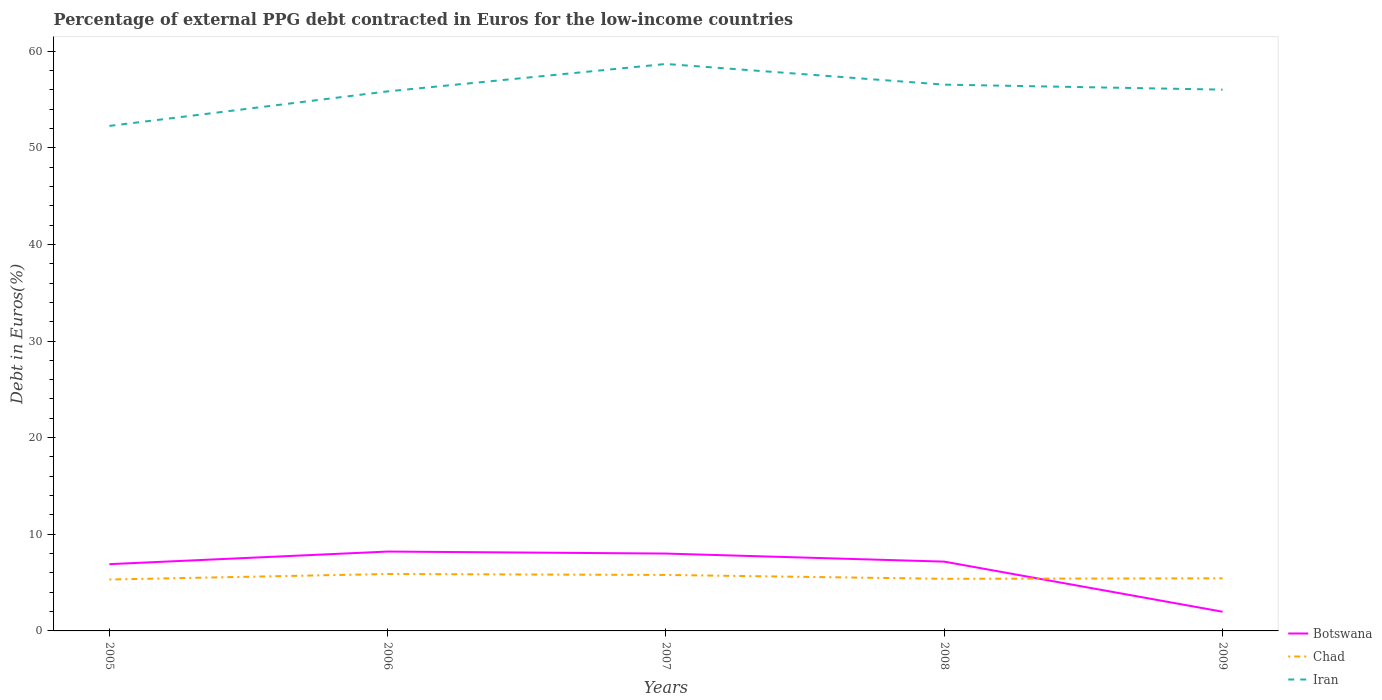Across all years, what is the maximum percentage of external PPG debt contracted in Euros in Chad?
Provide a succinct answer. 5.32. In which year was the percentage of external PPG debt contracted in Euros in Iran maximum?
Your answer should be compact. 2005. What is the total percentage of external PPG debt contracted in Euros in Iran in the graph?
Your answer should be compact. 2.66. What is the difference between the highest and the second highest percentage of external PPG debt contracted in Euros in Chad?
Provide a short and direct response. 0.57. What is the difference between the highest and the lowest percentage of external PPG debt contracted in Euros in Chad?
Offer a very short reply. 2. How many lines are there?
Keep it short and to the point. 3. How many years are there in the graph?
Your answer should be very brief. 5. What is the difference between two consecutive major ticks on the Y-axis?
Your response must be concise. 10. Does the graph contain any zero values?
Give a very brief answer. No. Where does the legend appear in the graph?
Provide a succinct answer. Bottom right. How many legend labels are there?
Ensure brevity in your answer.  3. What is the title of the graph?
Provide a short and direct response. Percentage of external PPG debt contracted in Euros for the low-income countries. What is the label or title of the X-axis?
Make the answer very short. Years. What is the label or title of the Y-axis?
Give a very brief answer. Debt in Euros(%). What is the Debt in Euros(%) of Botswana in 2005?
Ensure brevity in your answer.  6.91. What is the Debt in Euros(%) in Chad in 2005?
Ensure brevity in your answer.  5.32. What is the Debt in Euros(%) in Iran in 2005?
Give a very brief answer. 52.26. What is the Debt in Euros(%) in Botswana in 2006?
Your answer should be very brief. 8.21. What is the Debt in Euros(%) in Chad in 2006?
Keep it short and to the point. 5.89. What is the Debt in Euros(%) of Iran in 2006?
Give a very brief answer. 55.83. What is the Debt in Euros(%) in Botswana in 2007?
Your answer should be very brief. 8. What is the Debt in Euros(%) in Chad in 2007?
Make the answer very short. 5.79. What is the Debt in Euros(%) of Iran in 2007?
Your response must be concise. 58.67. What is the Debt in Euros(%) of Botswana in 2008?
Your answer should be compact. 7.17. What is the Debt in Euros(%) of Chad in 2008?
Offer a terse response. 5.39. What is the Debt in Euros(%) in Iran in 2008?
Make the answer very short. 56.53. What is the Debt in Euros(%) of Botswana in 2009?
Give a very brief answer. 1.99. What is the Debt in Euros(%) in Chad in 2009?
Provide a short and direct response. 5.44. What is the Debt in Euros(%) of Iran in 2009?
Provide a succinct answer. 56.01. Across all years, what is the maximum Debt in Euros(%) of Botswana?
Your answer should be compact. 8.21. Across all years, what is the maximum Debt in Euros(%) in Chad?
Ensure brevity in your answer.  5.89. Across all years, what is the maximum Debt in Euros(%) of Iran?
Your response must be concise. 58.67. Across all years, what is the minimum Debt in Euros(%) in Botswana?
Provide a short and direct response. 1.99. Across all years, what is the minimum Debt in Euros(%) in Chad?
Offer a terse response. 5.32. Across all years, what is the minimum Debt in Euros(%) of Iran?
Your answer should be very brief. 52.26. What is the total Debt in Euros(%) in Botswana in the graph?
Provide a short and direct response. 32.28. What is the total Debt in Euros(%) of Chad in the graph?
Ensure brevity in your answer.  27.84. What is the total Debt in Euros(%) of Iran in the graph?
Offer a very short reply. 279.31. What is the difference between the Debt in Euros(%) in Botswana in 2005 and that in 2006?
Offer a terse response. -1.3. What is the difference between the Debt in Euros(%) of Chad in 2005 and that in 2006?
Offer a terse response. -0.57. What is the difference between the Debt in Euros(%) in Iran in 2005 and that in 2006?
Your response must be concise. -3.58. What is the difference between the Debt in Euros(%) of Botswana in 2005 and that in 2007?
Ensure brevity in your answer.  -1.1. What is the difference between the Debt in Euros(%) in Chad in 2005 and that in 2007?
Your response must be concise. -0.47. What is the difference between the Debt in Euros(%) of Iran in 2005 and that in 2007?
Give a very brief answer. -6.41. What is the difference between the Debt in Euros(%) of Botswana in 2005 and that in 2008?
Your response must be concise. -0.26. What is the difference between the Debt in Euros(%) of Chad in 2005 and that in 2008?
Keep it short and to the point. -0.07. What is the difference between the Debt in Euros(%) of Iran in 2005 and that in 2008?
Your answer should be very brief. -4.27. What is the difference between the Debt in Euros(%) of Botswana in 2005 and that in 2009?
Keep it short and to the point. 4.92. What is the difference between the Debt in Euros(%) in Chad in 2005 and that in 2009?
Provide a short and direct response. -0.12. What is the difference between the Debt in Euros(%) in Iran in 2005 and that in 2009?
Your response must be concise. -3.76. What is the difference between the Debt in Euros(%) of Botswana in 2006 and that in 2007?
Give a very brief answer. 0.21. What is the difference between the Debt in Euros(%) of Chad in 2006 and that in 2007?
Your answer should be compact. 0.1. What is the difference between the Debt in Euros(%) in Iran in 2006 and that in 2007?
Your answer should be very brief. -2.84. What is the difference between the Debt in Euros(%) of Botswana in 2006 and that in 2008?
Offer a very short reply. 1.04. What is the difference between the Debt in Euros(%) of Chad in 2006 and that in 2008?
Ensure brevity in your answer.  0.5. What is the difference between the Debt in Euros(%) of Iran in 2006 and that in 2008?
Give a very brief answer. -0.7. What is the difference between the Debt in Euros(%) in Botswana in 2006 and that in 2009?
Offer a terse response. 6.23. What is the difference between the Debt in Euros(%) in Chad in 2006 and that in 2009?
Give a very brief answer. 0.45. What is the difference between the Debt in Euros(%) in Iran in 2006 and that in 2009?
Keep it short and to the point. -0.18. What is the difference between the Debt in Euros(%) in Botswana in 2007 and that in 2008?
Your answer should be compact. 0.83. What is the difference between the Debt in Euros(%) of Chad in 2007 and that in 2008?
Offer a very short reply. 0.4. What is the difference between the Debt in Euros(%) in Iran in 2007 and that in 2008?
Offer a terse response. 2.14. What is the difference between the Debt in Euros(%) of Botswana in 2007 and that in 2009?
Offer a very short reply. 6.02. What is the difference between the Debt in Euros(%) in Chad in 2007 and that in 2009?
Your answer should be compact. 0.35. What is the difference between the Debt in Euros(%) in Iran in 2007 and that in 2009?
Give a very brief answer. 2.66. What is the difference between the Debt in Euros(%) of Botswana in 2008 and that in 2009?
Offer a very short reply. 5.18. What is the difference between the Debt in Euros(%) of Chad in 2008 and that in 2009?
Your answer should be compact. -0.05. What is the difference between the Debt in Euros(%) of Iran in 2008 and that in 2009?
Provide a succinct answer. 0.52. What is the difference between the Debt in Euros(%) of Botswana in 2005 and the Debt in Euros(%) of Chad in 2006?
Your response must be concise. 1.02. What is the difference between the Debt in Euros(%) in Botswana in 2005 and the Debt in Euros(%) in Iran in 2006?
Make the answer very short. -48.92. What is the difference between the Debt in Euros(%) in Chad in 2005 and the Debt in Euros(%) in Iran in 2006?
Make the answer very short. -50.51. What is the difference between the Debt in Euros(%) of Botswana in 2005 and the Debt in Euros(%) of Chad in 2007?
Offer a very short reply. 1.12. What is the difference between the Debt in Euros(%) in Botswana in 2005 and the Debt in Euros(%) in Iran in 2007?
Give a very brief answer. -51.76. What is the difference between the Debt in Euros(%) of Chad in 2005 and the Debt in Euros(%) of Iran in 2007?
Give a very brief answer. -53.35. What is the difference between the Debt in Euros(%) in Botswana in 2005 and the Debt in Euros(%) in Chad in 2008?
Offer a terse response. 1.51. What is the difference between the Debt in Euros(%) in Botswana in 2005 and the Debt in Euros(%) in Iran in 2008?
Your response must be concise. -49.62. What is the difference between the Debt in Euros(%) of Chad in 2005 and the Debt in Euros(%) of Iran in 2008?
Provide a succinct answer. -51.21. What is the difference between the Debt in Euros(%) in Botswana in 2005 and the Debt in Euros(%) in Chad in 2009?
Provide a succinct answer. 1.46. What is the difference between the Debt in Euros(%) in Botswana in 2005 and the Debt in Euros(%) in Iran in 2009?
Your response must be concise. -49.1. What is the difference between the Debt in Euros(%) of Chad in 2005 and the Debt in Euros(%) of Iran in 2009?
Offer a terse response. -50.69. What is the difference between the Debt in Euros(%) in Botswana in 2006 and the Debt in Euros(%) in Chad in 2007?
Your answer should be compact. 2.42. What is the difference between the Debt in Euros(%) of Botswana in 2006 and the Debt in Euros(%) of Iran in 2007?
Give a very brief answer. -50.46. What is the difference between the Debt in Euros(%) in Chad in 2006 and the Debt in Euros(%) in Iran in 2007?
Your response must be concise. -52.78. What is the difference between the Debt in Euros(%) of Botswana in 2006 and the Debt in Euros(%) of Chad in 2008?
Ensure brevity in your answer.  2.82. What is the difference between the Debt in Euros(%) of Botswana in 2006 and the Debt in Euros(%) of Iran in 2008?
Give a very brief answer. -48.32. What is the difference between the Debt in Euros(%) of Chad in 2006 and the Debt in Euros(%) of Iran in 2008?
Your answer should be very brief. -50.64. What is the difference between the Debt in Euros(%) of Botswana in 2006 and the Debt in Euros(%) of Chad in 2009?
Keep it short and to the point. 2.77. What is the difference between the Debt in Euros(%) of Botswana in 2006 and the Debt in Euros(%) of Iran in 2009?
Offer a very short reply. -47.8. What is the difference between the Debt in Euros(%) in Chad in 2006 and the Debt in Euros(%) in Iran in 2009?
Ensure brevity in your answer.  -50.12. What is the difference between the Debt in Euros(%) of Botswana in 2007 and the Debt in Euros(%) of Chad in 2008?
Your answer should be very brief. 2.61. What is the difference between the Debt in Euros(%) of Botswana in 2007 and the Debt in Euros(%) of Iran in 2008?
Make the answer very short. -48.53. What is the difference between the Debt in Euros(%) in Chad in 2007 and the Debt in Euros(%) in Iran in 2008?
Provide a succinct answer. -50.74. What is the difference between the Debt in Euros(%) in Botswana in 2007 and the Debt in Euros(%) in Chad in 2009?
Provide a succinct answer. 2.56. What is the difference between the Debt in Euros(%) in Botswana in 2007 and the Debt in Euros(%) in Iran in 2009?
Your answer should be very brief. -48.01. What is the difference between the Debt in Euros(%) of Chad in 2007 and the Debt in Euros(%) of Iran in 2009?
Provide a succinct answer. -50.22. What is the difference between the Debt in Euros(%) of Botswana in 2008 and the Debt in Euros(%) of Chad in 2009?
Your answer should be very brief. 1.73. What is the difference between the Debt in Euros(%) in Botswana in 2008 and the Debt in Euros(%) in Iran in 2009?
Offer a very short reply. -48.84. What is the difference between the Debt in Euros(%) in Chad in 2008 and the Debt in Euros(%) in Iran in 2009?
Provide a short and direct response. -50.62. What is the average Debt in Euros(%) of Botswana per year?
Offer a very short reply. 6.46. What is the average Debt in Euros(%) of Chad per year?
Your answer should be compact. 5.57. What is the average Debt in Euros(%) in Iran per year?
Keep it short and to the point. 55.86. In the year 2005, what is the difference between the Debt in Euros(%) in Botswana and Debt in Euros(%) in Chad?
Your response must be concise. 1.59. In the year 2005, what is the difference between the Debt in Euros(%) of Botswana and Debt in Euros(%) of Iran?
Give a very brief answer. -45.35. In the year 2005, what is the difference between the Debt in Euros(%) of Chad and Debt in Euros(%) of Iran?
Ensure brevity in your answer.  -46.94. In the year 2006, what is the difference between the Debt in Euros(%) of Botswana and Debt in Euros(%) of Chad?
Provide a short and direct response. 2.32. In the year 2006, what is the difference between the Debt in Euros(%) of Botswana and Debt in Euros(%) of Iran?
Your answer should be very brief. -47.62. In the year 2006, what is the difference between the Debt in Euros(%) of Chad and Debt in Euros(%) of Iran?
Your answer should be compact. -49.94. In the year 2007, what is the difference between the Debt in Euros(%) in Botswana and Debt in Euros(%) in Chad?
Offer a very short reply. 2.21. In the year 2007, what is the difference between the Debt in Euros(%) of Botswana and Debt in Euros(%) of Iran?
Ensure brevity in your answer.  -50.67. In the year 2007, what is the difference between the Debt in Euros(%) of Chad and Debt in Euros(%) of Iran?
Provide a short and direct response. -52.88. In the year 2008, what is the difference between the Debt in Euros(%) in Botswana and Debt in Euros(%) in Chad?
Keep it short and to the point. 1.78. In the year 2008, what is the difference between the Debt in Euros(%) of Botswana and Debt in Euros(%) of Iran?
Provide a succinct answer. -49.36. In the year 2008, what is the difference between the Debt in Euros(%) of Chad and Debt in Euros(%) of Iran?
Your answer should be very brief. -51.14. In the year 2009, what is the difference between the Debt in Euros(%) of Botswana and Debt in Euros(%) of Chad?
Provide a succinct answer. -3.46. In the year 2009, what is the difference between the Debt in Euros(%) of Botswana and Debt in Euros(%) of Iran?
Your response must be concise. -54.03. In the year 2009, what is the difference between the Debt in Euros(%) in Chad and Debt in Euros(%) in Iran?
Keep it short and to the point. -50.57. What is the ratio of the Debt in Euros(%) of Botswana in 2005 to that in 2006?
Keep it short and to the point. 0.84. What is the ratio of the Debt in Euros(%) in Chad in 2005 to that in 2006?
Give a very brief answer. 0.9. What is the ratio of the Debt in Euros(%) in Iran in 2005 to that in 2006?
Your answer should be compact. 0.94. What is the ratio of the Debt in Euros(%) in Botswana in 2005 to that in 2007?
Offer a terse response. 0.86. What is the ratio of the Debt in Euros(%) of Chad in 2005 to that in 2007?
Your answer should be very brief. 0.92. What is the ratio of the Debt in Euros(%) in Iran in 2005 to that in 2007?
Make the answer very short. 0.89. What is the ratio of the Debt in Euros(%) in Botswana in 2005 to that in 2008?
Your response must be concise. 0.96. What is the ratio of the Debt in Euros(%) of Chad in 2005 to that in 2008?
Your answer should be very brief. 0.99. What is the ratio of the Debt in Euros(%) in Iran in 2005 to that in 2008?
Ensure brevity in your answer.  0.92. What is the ratio of the Debt in Euros(%) in Botswana in 2005 to that in 2009?
Provide a succinct answer. 3.48. What is the ratio of the Debt in Euros(%) in Chad in 2005 to that in 2009?
Your response must be concise. 0.98. What is the ratio of the Debt in Euros(%) in Iran in 2005 to that in 2009?
Provide a succinct answer. 0.93. What is the ratio of the Debt in Euros(%) of Botswana in 2006 to that in 2007?
Provide a short and direct response. 1.03. What is the ratio of the Debt in Euros(%) of Chad in 2006 to that in 2007?
Make the answer very short. 1.02. What is the ratio of the Debt in Euros(%) in Iran in 2006 to that in 2007?
Keep it short and to the point. 0.95. What is the ratio of the Debt in Euros(%) of Botswana in 2006 to that in 2008?
Your answer should be compact. 1.15. What is the ratio of the Debt in Euros(%) of Chad in 2006 to that in 2008?
Ensure brevity in your answer.  1.09. What is the ratio of the Debt in Euros(%) of Iran in 2006 to that in 2008?
Offer a very short reply. 0.99. What is the ratio of the Debt in Euros(%) in Botswana in 2006 to that in 2009?
Ensure brevity in your answer.  4.13. What is the ratio of the Debt in Euros(%) in Chad in 2006 to that in 2009?
Provide a short and direct response. 1.08. What is the ratio of the Debt in Euros(%) of Iran in 2006 to that in 2009?
Offer a very short reply. 1. What is the ratio of the Debt in Euros(%) of Botswana in 2007 to that in 2008?
Provide a short and direct response. 1.12. What is the ratio of the Debt in Euros(%) of Chad in 2007 to that in 2008?
Provide a short and direct response. 1.07. What is the ratio of the Debt in Euros(%) of Iran in 2007 to that in 2008?
Ensure brevity in your answer.  1.04. What is the ratio of the Debt in Euros(%) of Botswana in 2007 to that in 2009?
Offer a very short reply. 4.03. What is the ratio of the Debt in Euros(%) of Chad in 2007 to that in 2009?
Your answer should be compact. 1.06. What is the ratio of the Debt in Euros(%) of Iran in 2007 to that in 2009?
Keep it short and to the point. 1.05. What is the ratio of the Debt in Euros(%) in Botswana in 2008 to that in 2009?
Your answer should be very brief. 3.61. What is the ratio of the Debt in Euros(%) of Chad in 2008 to that in 2009?
Your response must be concise. 0.99. What is the ratio of the Debt in Euros(%) of Iran in 2008 to that in 2009?
Your response must be concise. 1.01. What is the difference between the highest and the second highest Debt in Euros(%) of Botswana?
Offer a terse response. 0.21. What is the difference between the highest and the second highest Debt in Euros(%) in Chad?
Give a very brief answer. 0.1. What is the difference between the highest and the second highest Debt in Euros(%) in Iran?
Ensure brevity in your answer.  2.14. What is the difference between the highest and the lowest Debt in Euros(%) of Botswana?
Give a very brief answer. 6.23. What is the difference between the highest and the lowest Debt in Euros(%) of Chad?
Your answer should be compact. 0.57. What is the difference between the highest and the lowest Debt in Euros(%) of Iran?
Ensure brevity in your answer.  6.41. 